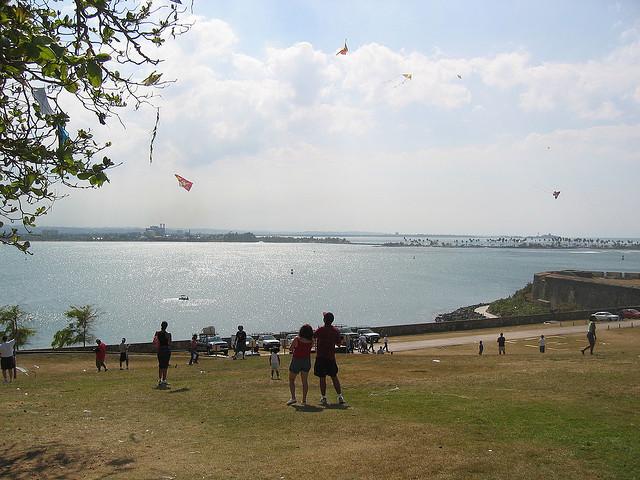How many cars can you see?
Quick response, please. 8. Is the park empty?
Keep it brief. No. What color are the flowers?
Be succinct. No flowers. Are the mammals close to each other?
Keep it brief. Yes. Are there a lot of stress?
Quick response, please. No. How many people do you see?
Concise answer only. 13. Where is this at?
Be succinct. Beach. Was it taken in the wild?
Concise answer only. No. Is this a shaded area?
Short answer required. No. What color is the woman's shirt?
Answer briefly. Red. Is the boy throwing the object?
Concise answer only. No. Is there any sand in this picture?
Answer briefly. No. How many children are shown?
Give a very brief answer. 6. Are there people in this photo?
Be succinct. Yes. Are any of the structures in the picture man made?
Quick response, please. Yes. How many people are playing?
Answer briefly. 13. Is there a person on the bench?
Give a very brief answer. No. Are the trees leafed out?
Concise answer only. Yes. Where is this being played?
Concise answer only. Beach. What are the people doing?
Answer briefly. Flying kites. Is the grass green?
Keep it brief. Yes. How many people are here?
Concise answer only. 13. What season was this taken during?
Quick response, please. Summer. How many kites are in the sky?
Answer briefly. 5. How many boats are in the water?
Answer briefly. 1. How many people are in the photo?
Answer briefly. 13. Is this next to a lake?
Answer briefly. Yes. How long have the couple been on the bench?
Write a very short answer. All day. Is this a lake or a stream?
Short answer required. Lake. Is the park crowded?
Concise answer only. No. Are there birds in the photo?
Quick response, please. No. Where are these people at?
Quick response, please. Park. Is it sunny here?
Be succinct. Yes. Are there just a couple trees?
Give a very brief answer. Yes. What is the boy holding?
Quick response, please. Kite. How many people?
Give a very brief answer. 13. Where are these people?
Give a very brief answer. Park. Is this a shady area?
Answer briefly. No. What is the name for this sort of body of water?
Short answer required. Lake. Is this at a beach?
Answer briefly. Yes. Are they at the beach?
Answer briefly. Yes. Is this area sunny?
Give a very brief answer. Yes. What is the weather scene?
Give a very brief answer. Partly cloudy. Was this photo taken in the middle of summer?
Short answer required. Yes. What type of weather is pictured?
Keep it brief. Sunny. Is this a tropical scene?
Write a very short answer. No. What is the predominant color of this photo?
Quick response, please. Blue. What type of park is this?
Give a very brief answer. City. What color are the stones?
Concise answer only. Gray. Are there any people?
Be succinct. Yes. What are the people looking at?
Give a very brief answer. Kites. What two surfaces are shown?
Keep it brief. Water and land. Is this a park?
Quick response, please. Yes. 